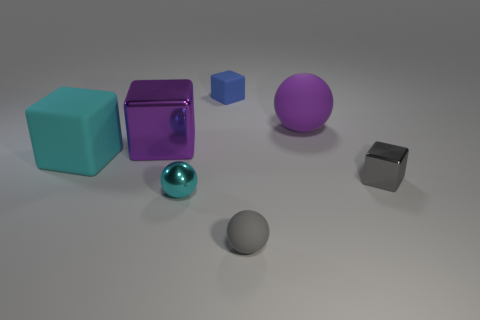Subtract all purple shiny cubes. How many cubes are left? 3 Subtract all purple blocks. How many blocks are left? 3 Add 1 small red matte cylinders. How many objects exist? 8 Subtract all brown blocks. Subtract all red cylinders. How many blocks are left? 4 Subtract all blocks. How many objects are left? 3 Subtract 0 red balls. How many objects are left? 7 Subtract all gray metal cylinders. Subtract all blue matte cubes. How many objects are left? 6 Add 5 rubber balls. How many rubber balls are left? 7 Add 6 yellow rubber cubes. How many yellow rubber cubes exist? 6 